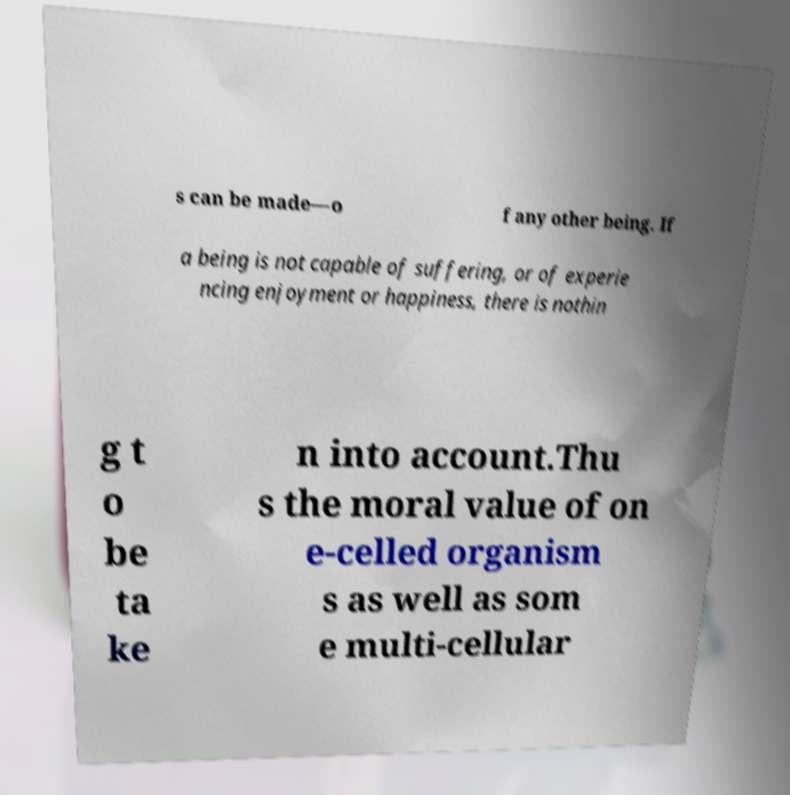I need the written content from this picture converted into text. Can you do that? s can be made—o f any other being. If a being is not capable of suffering, or of experie ncing enjoyment or happiness, there is nothin g t o be ta ke n into account.Thu s the moral value of on e-celled organism s as well as som e multi-cellular 